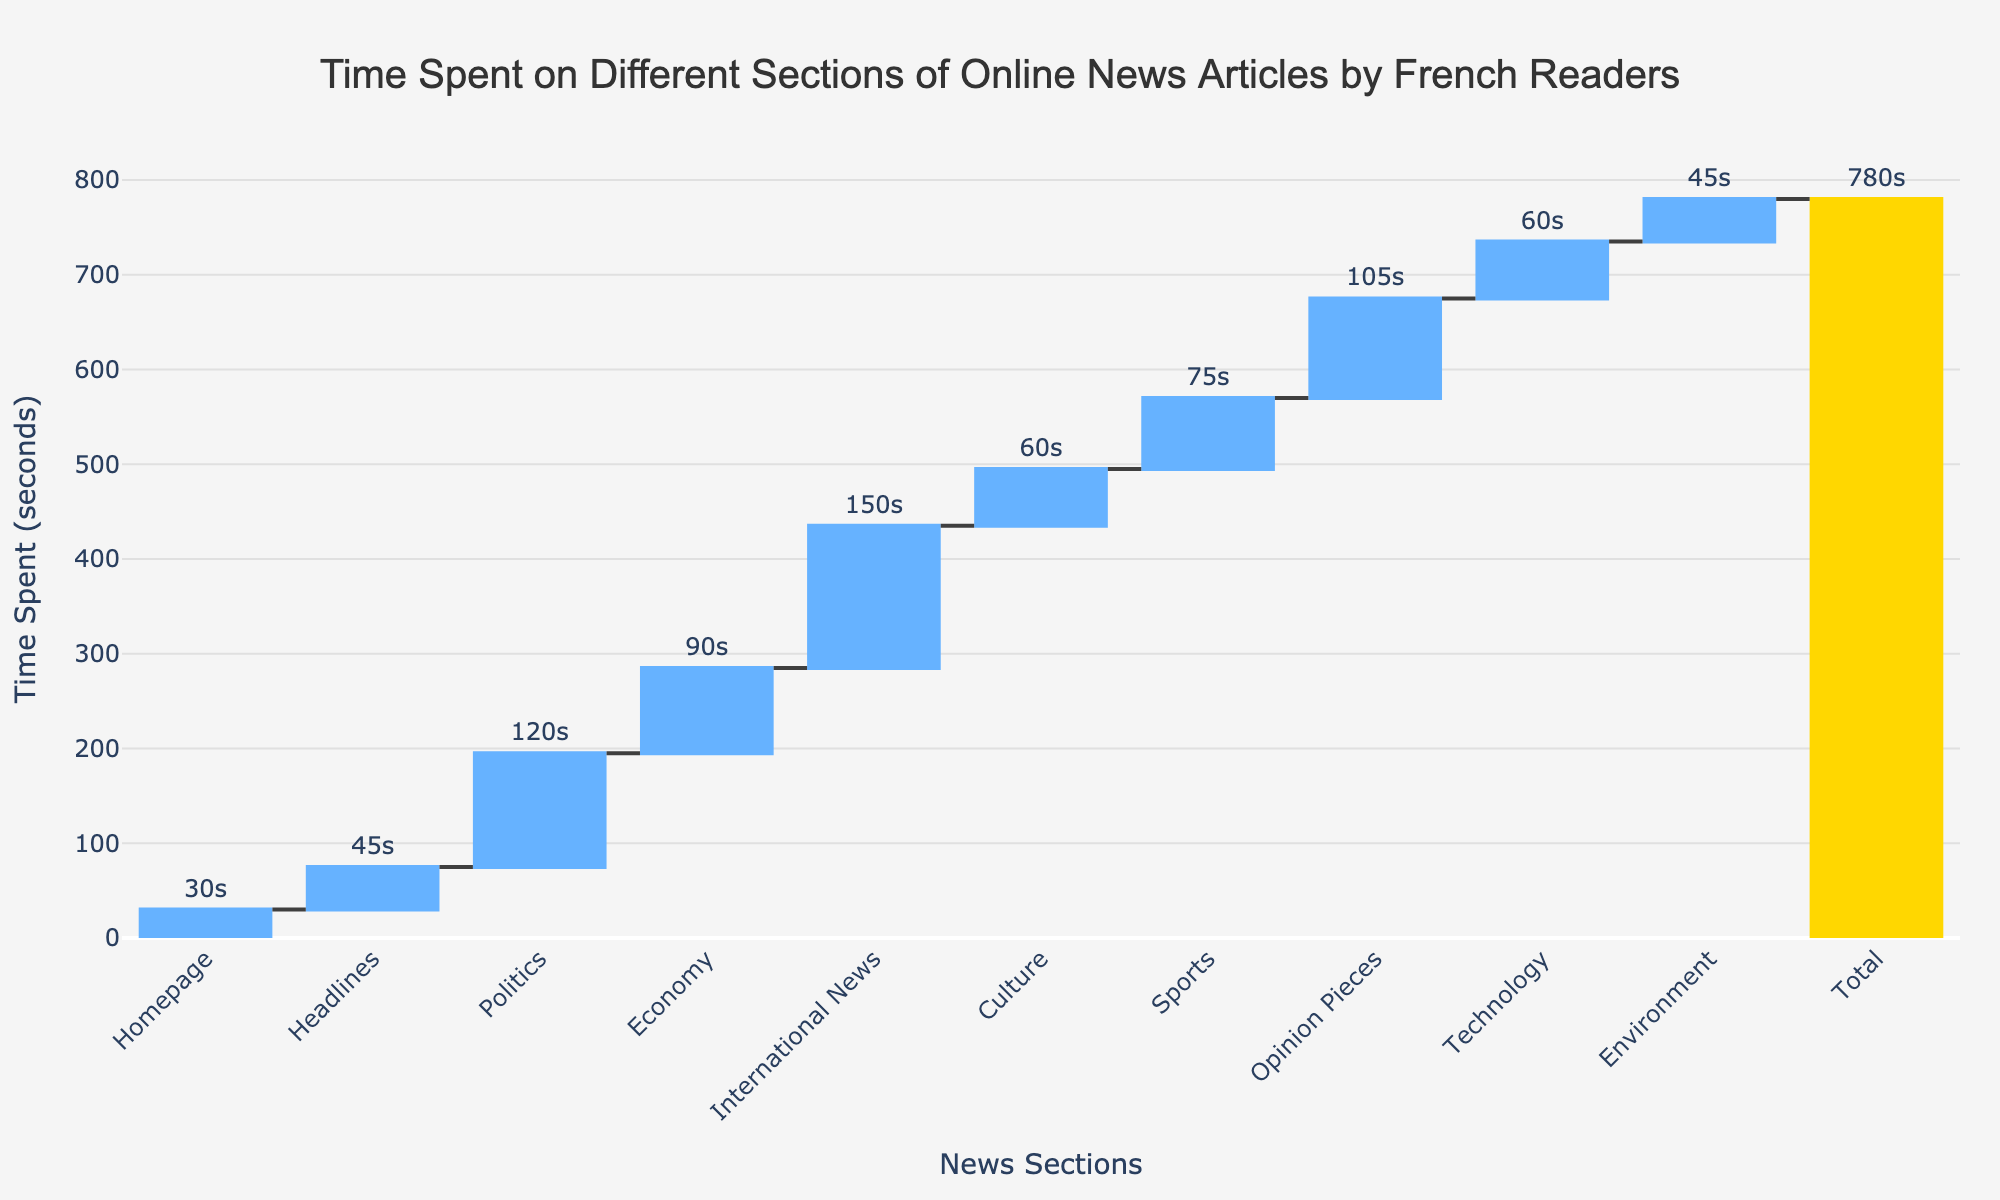What is the title of the figure? The title is usually the largest text on the figure, displayed at the top and provides an overview of the chart. The title here is centered and highlighted.
Answer: Time Spent on Different Sections of Online News Articles by French Readers Which section do French readers spend the most time on? Comparing the visual heights of the bars along the y-axis, the tallest bar indicates the section with the maximum time spent.
Answer: International News What is the total cumulative time spent on the Homepage, Headlines, and Politics sections? Sum the time spent on the Homepage (30s), Headlines (45s), and Politics (120s). Therefore, 30 + 45 + 120 = 195 seconds.
Answer: 195 seconds Which section has the same time spent as the Culture section? By visually inspecting and comparing the lengths of the bars, we find that the Technology section has a bar equal in height to the Culture section.
Answer: Technology How does the time spent on Sports compare to Opinion Pieces? The bar for Sports (75s) is visually shorter than the bar for Opinion Pieces (105s). Hence, less time is spent on Sports compared to Opinion Pieces.
Answer: Less Which sections have a time spent that is below 60 seconds? Scanning through the heights of the bars and checking their labels, the sections are Homepage (30s), Headlines (45s), Technology (60s), and Environment (45s).
Answer: Homepage, Headlines, Environment What is the average time spent per section (excluding the total)? Sum the times of all sections given (30 + 45 + 120 + 90 + 150 + 60 + 75 + 105 + 60 + 45 = 780). Then divide by the number of sections (10). So, 780 / 10 = 78 seconds.
Answer: 78 seconds What are the two sections with the least time spent? By identifying the two shortest bars within the chart, we determine that Homepage (30s) and Headlines (45s) are the two sections with the least time spent.
Answer: Homepage, Headlines What percentage of the total time is spent on the Politics section? Calculate the percentage by dividing the time spent on Politics (120s) by the total time (780s) and then multiply by 100. (120 / 780) * 100 ≈ 15.38%.
Answer: 15.38% How does the time spent on Culture compare to Technology? Checking the bar lengths, we observe that the bars for both Culture and Technology are of equal height, indicating an equal time spent on both sections. Both are 60 seconds.
Answer: Equal 